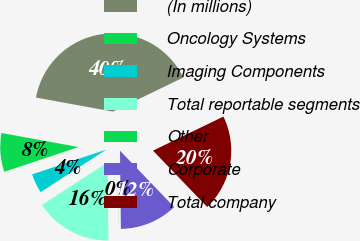Convert chart to OTSL. <chart><loc_0><loc_0><loc_500><loc_500><pie_chart><fcel>(In millions)<fcel>Oncology Systems<fcel>Imaging Components<fcel>Total reportable segments<fcel>Other<fcel>Corporate<fcel>Total company<nl><fcel>39.95%<fcel>8.01%<fcel>4.02%<fcel>16.0%<fcel>0.03%<fcel>12.0%<fcel>19.99%<nl></chart> 